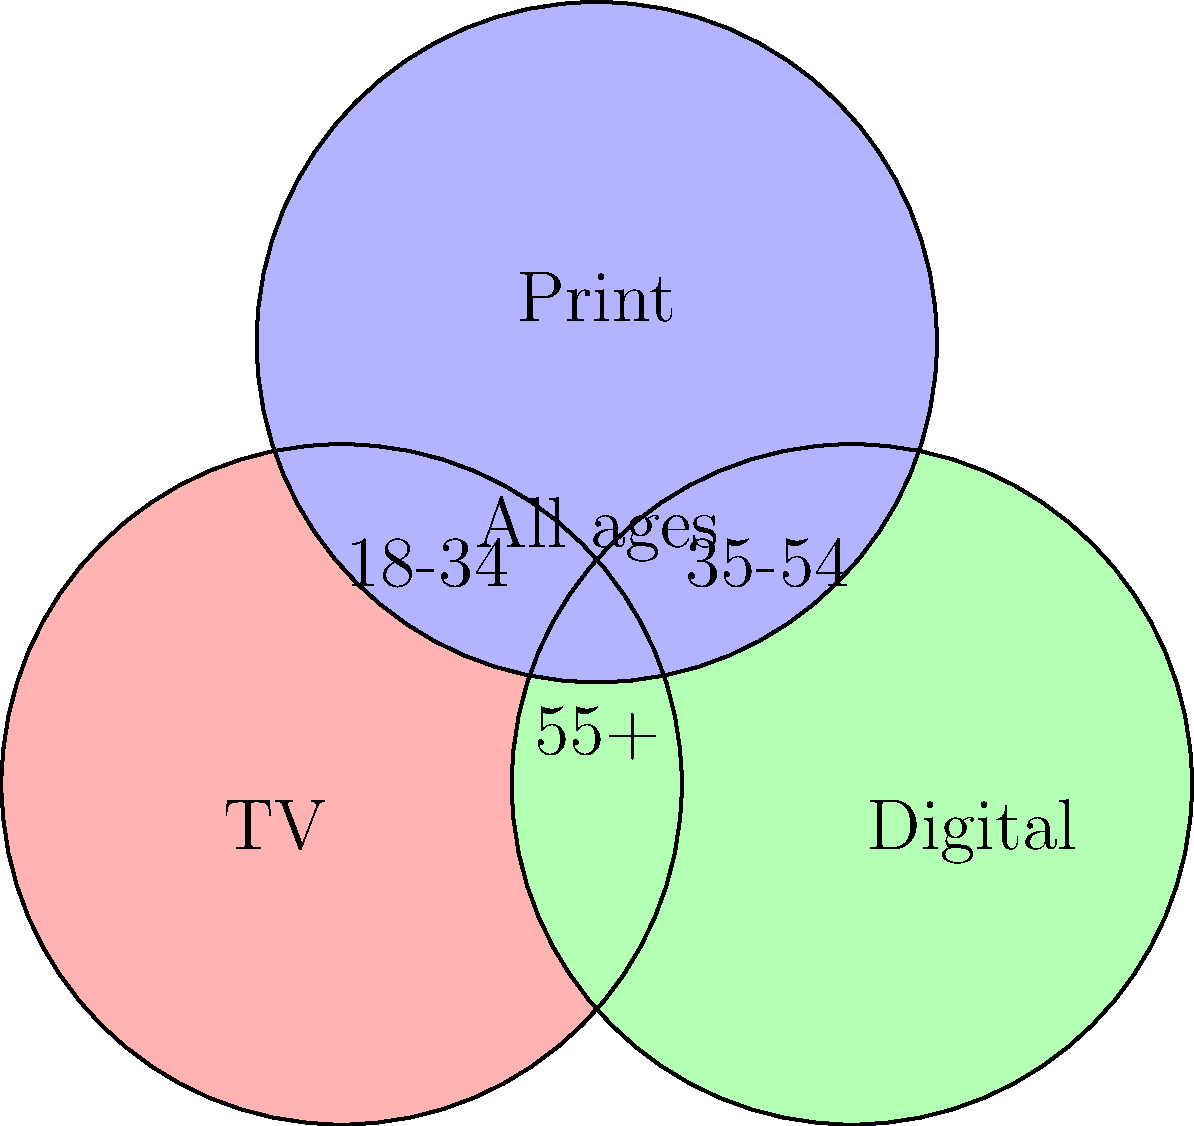As a media rights broker, you're analyzing audience demographics across different media formats. The Venn diagram shows overlapping audience segments for TV, Digital, and Print media. Which age group is represented in the central overlapping area of all three media formats, indicating a potential multi-platform strategy for reaching this demographic? To answer this question, let's analyze the Venn diagram step-by-step:

1. The diagram shows three overlapping circles representing TV, Digital, and Print media.

2. Each circle contains specific age group labels:
   - TV (red circle): 18-34
   - Digital (green circle): 35-54
   - Print (blue circle): 55+

3. The central area where all three circles overlap is labeled "All ages".

4. This central overlapping area represents the audience segment that consumes content across all three media formats: TV, Digital, and Print.

5. The label "All ages" in this central area indicates that this segment includes people from all age groups, not limited to a specific demographic.

6. From a strategic perspective, this overlap suggests that a multi-platform approach targeting all age groups could be effective in reaching a diverse audience across different media formats.

Therefore, the age group represented in the central overlapping area is not a specific demographic, but rather encompasses all age groups.
Answer: All ages 